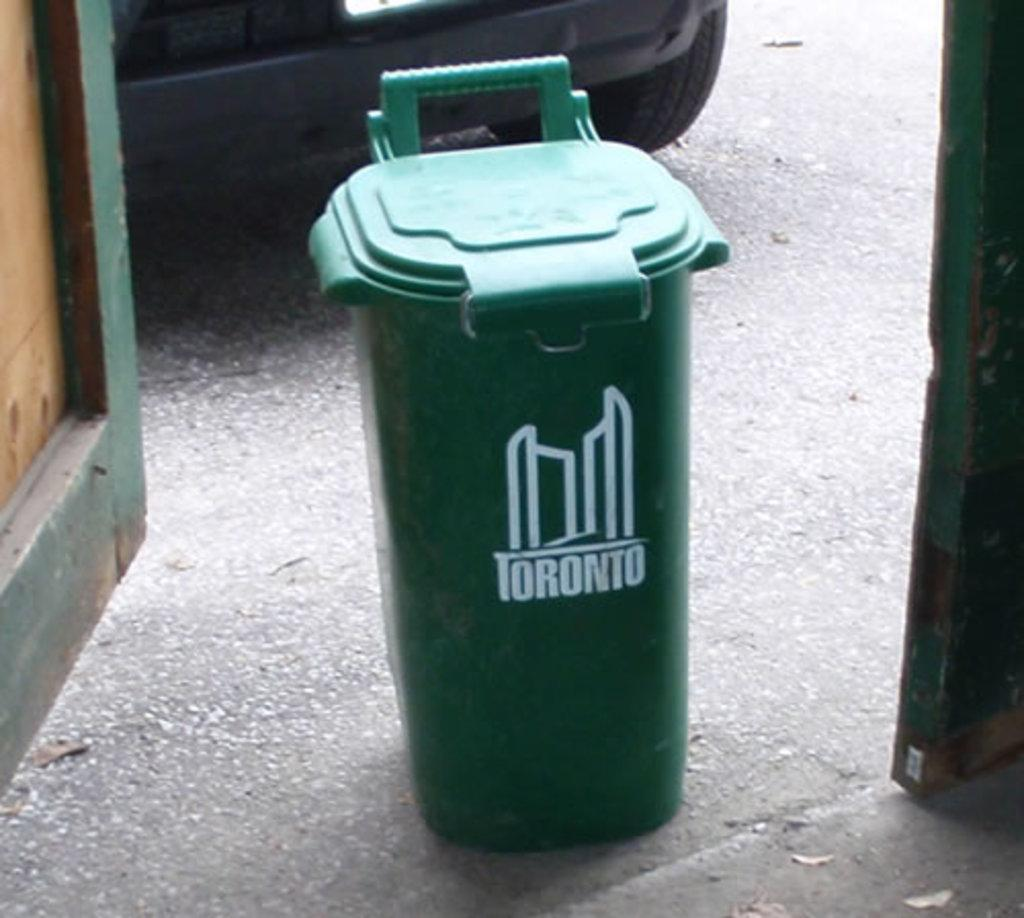<image>
Give a short and clear explanation of the subsequent image. a bin wit the word Toronto on it 